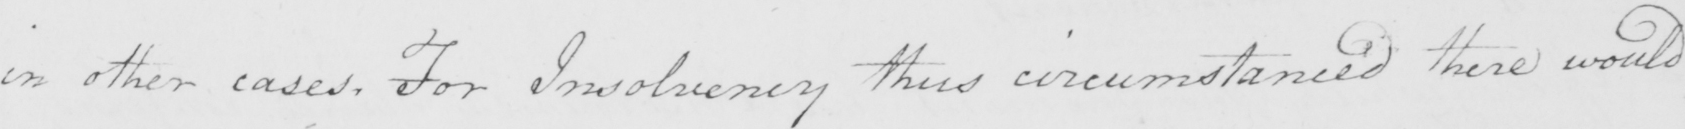Can you read and transcribe this handwriting? in other cases . For Insolvency thus circumstanced there would 